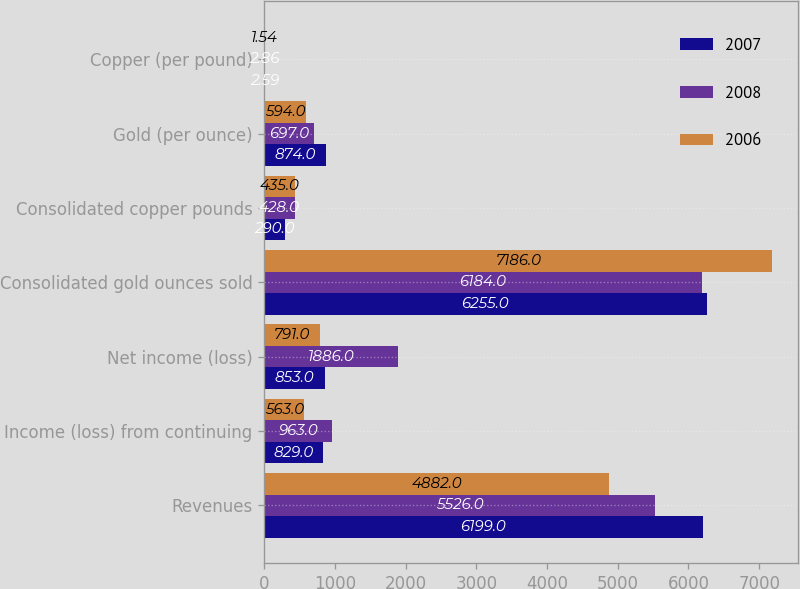Convert chart to OTSL. <chart><loc_0><loc_0><loc_500><loc_500><stacked_bar_chart><ecel><fcel>Revenues<fcel>Income (loss) from continuing<fcel>Net income (loss)<fcel>Consolidated gold ounces sold<fcel>Consolidated copper pounds<fcel>Gold (per ounce)<fcel>Copper (per pound)<nl><fcel>2007<fcel>6199<fcel>829<fcel>853<fcel>6255<fcel>290<fcel>874<fcel>2.59<nl><fcel>2008<fcel>5526<fcel>963<fcel>1886<fcel>6184<fcel>428<fcel>697<fcel>2.86<nl><fcel>2006<fcel>4882<fcel>563<fcel>791<fcel>7186<fcel>435<fcel>594<fcel>1.54<nl></chart> 